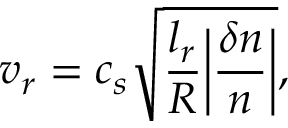<formula> <loc_0><loc_0><loc_500><loc_500>v _ { r } = c _ { s } \sqrt { \frac { l _ { r } } { R } \left | \frac { \delta n } { n } \right | } ,</formula> 